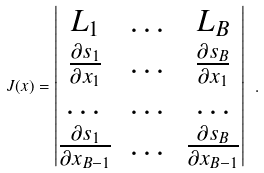<formula> <loc_0><loc_0><loc_500><loc_500>J ( x ) = \begin{vmatrix} L _ { 1 } & \dots & L _ { B } \\ \frac { \partial s _ { 1 } } { \partial x _ { 1 } } & \dots & \frac { \partial s _ { B } } { \partial x _ { 1 } } \\ \dots & \dots & \dots \\ \frac { \partial s _ { 1 } } { \partial x _ { B - 1 } } & \dots & \frac { \partial s _ { B } } { \partial x _ { B - 1 } } \end{vmatrix} \ .</formula> 